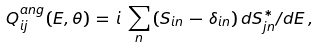Convert formula to latex. <formula><loc_0><loc_0><loc_500><loc_500>Q ^ { a n g } _ { i j } ( E , \theta ) \, = \, i \, \hbar { \, } \sum _ { n } \, ( S _ { i n } \, - \, \delta _ { i n } ) \, d S ^ { * } _ { j n } / d E \, ,</formula> 